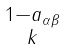<formula> <loc_0><loc_0><loc_500><loc_500>\begin{smallmatrix} 1 - a _ { \alpha \beta } \\ k \end{smallmatrix}</formula> 